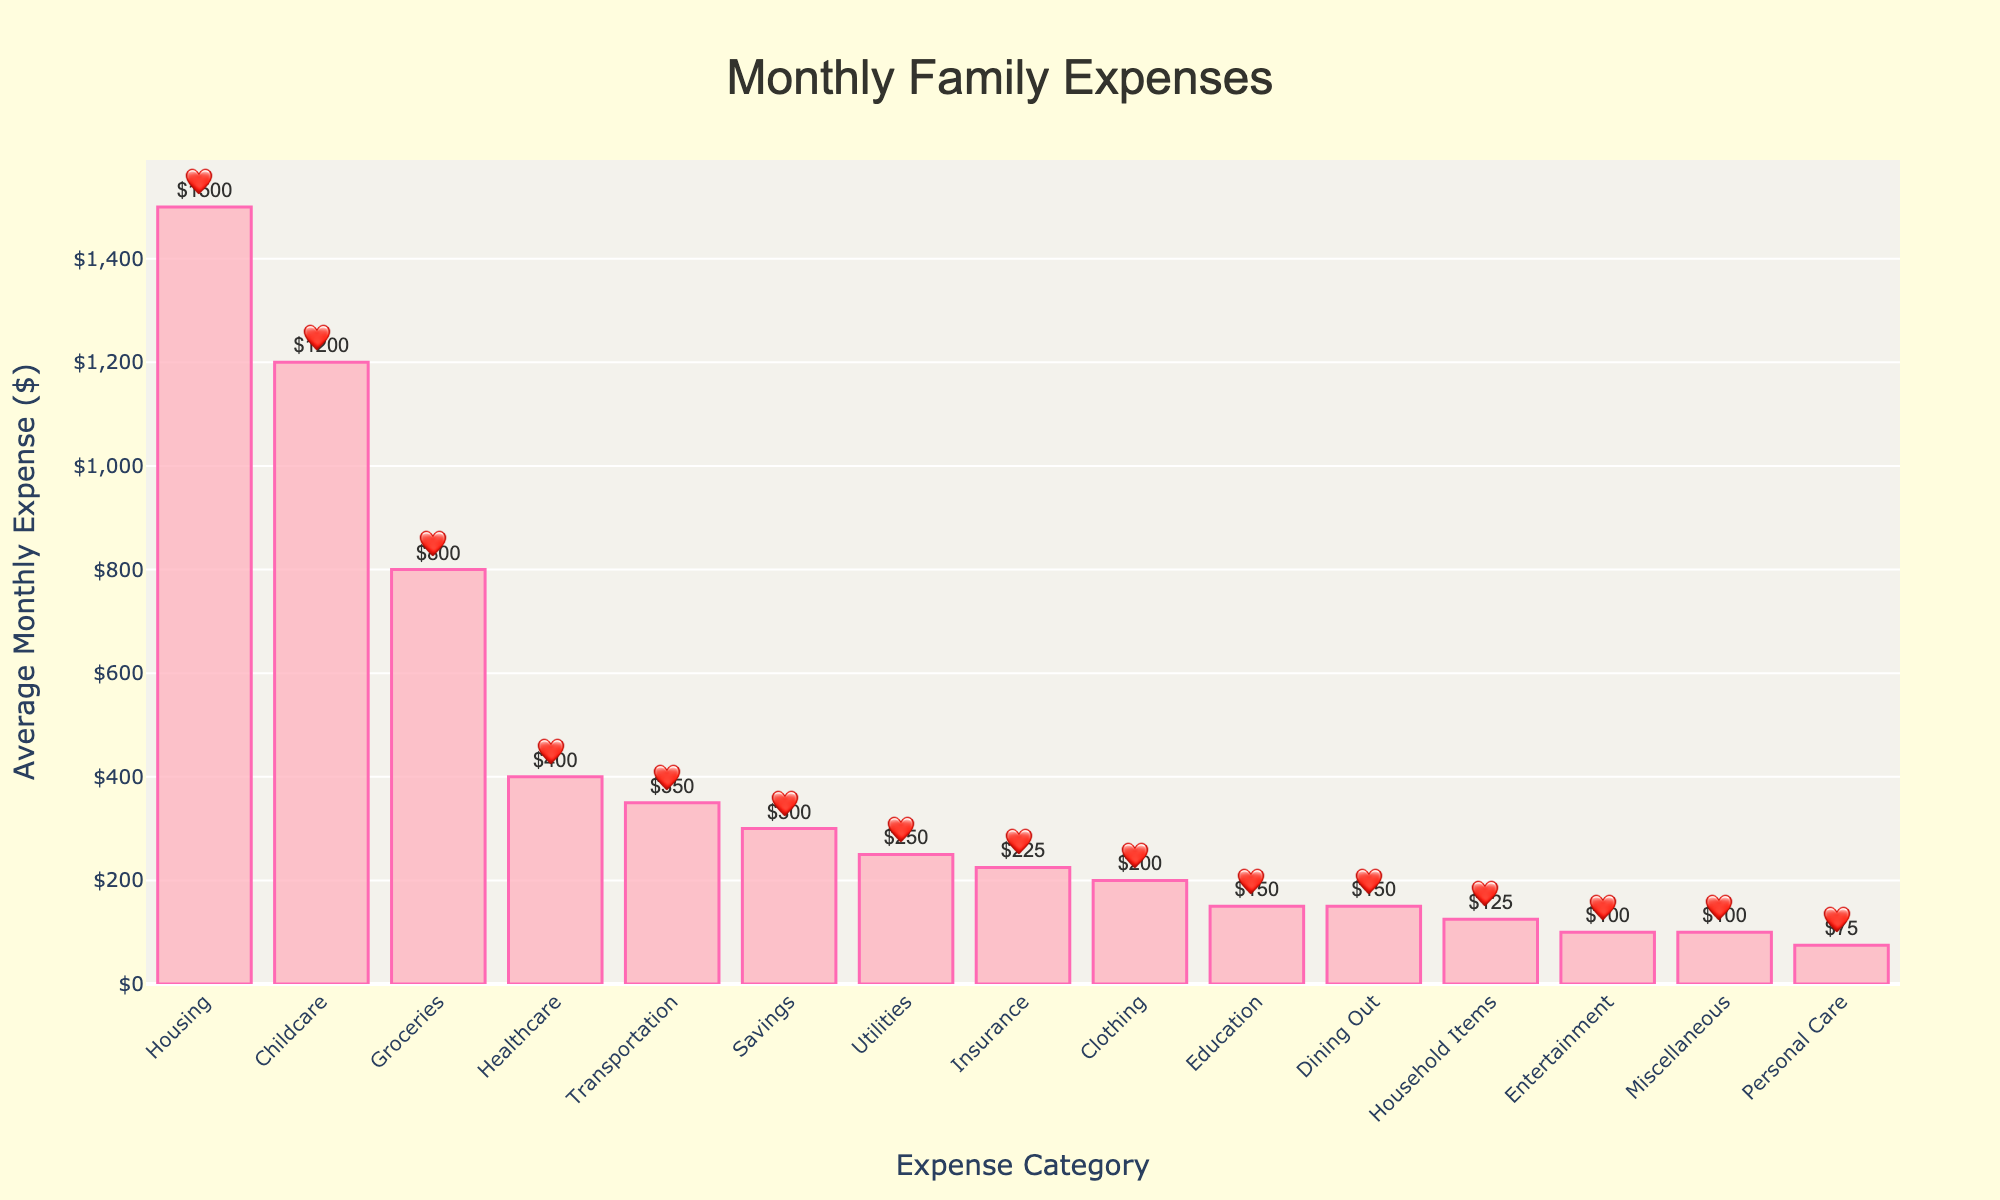Which expense category has the highest average monthly expense? The highest bar represents the category with the highest expense. The Housing bar is the tallest, indicating the highest expense.
Answer: Housing What is the total average monthly expense for Housing, Groceries, and Childcare? Sum the values of Housing ($1500), Groceries ($800), and Childcare ($1200). 1500 + 800 + 1200 = 3500
Answer: 3500 Which category has the lowest average monthly expense? The shortest bar represents the category with the lowest expense. The Entertainment and Miscellaneous bars are the shortest, both indicating $100.
Answer: Entertainment or Miscellaneous How much more is spent on Childcare compared to Healthcare? Subtract the Healthcare expense ($400) from the Childcare expense ($1200). 1200 - 400 = 800
Answer: 800 What is the average monthly expense difference between Transportation and Clothing? Subtract the Clothing expense ($200) from the Transportation expense ($350). 350 - 200 = 150
Answer: 150 Can you list the categories whose expenses are less than $300? Look for bars shorter than the $300 mark. Categories are Utilities ($250), Clothing ($200), Education ($150), Entertainment ($100), Personal Care ($75), Household Items ($125), and Miscellaneous ($100).
Answer: Utilities, Clothing, Education, Entertainment, Personal Care, Household Items, Miscellaneous How does the monthly expense for Childcare compare to Groceries? Compare the heights of the Childcare and Groceries bars. The Childcare bar is taller than the Groceries bar: $1200 for Childcare and $800 for Groceries.
Answer: Childcare is higher Which categories have an average monthly expense of exactly $150? Locate the bars labeled with $150. Education and Dining Out categories meet this criterion.
Answer: Education and Dining Out What is the combined average monthly expense for Utilities, Clothing, and Personal Care? Sum the values: Utilities ($250), Clothing ($200), and Personal Care ($75). 250 + 200 + 75 = 525
Answer: 525 Is the expense for Savings higher or lower than Healthcare? By how much? Compare the Savings bar ($300) with the Healthcare bar ($400). Savings is lower. Subtract the smaller from the larger: 400 - 300 = 100
Answer: Lower by 100 